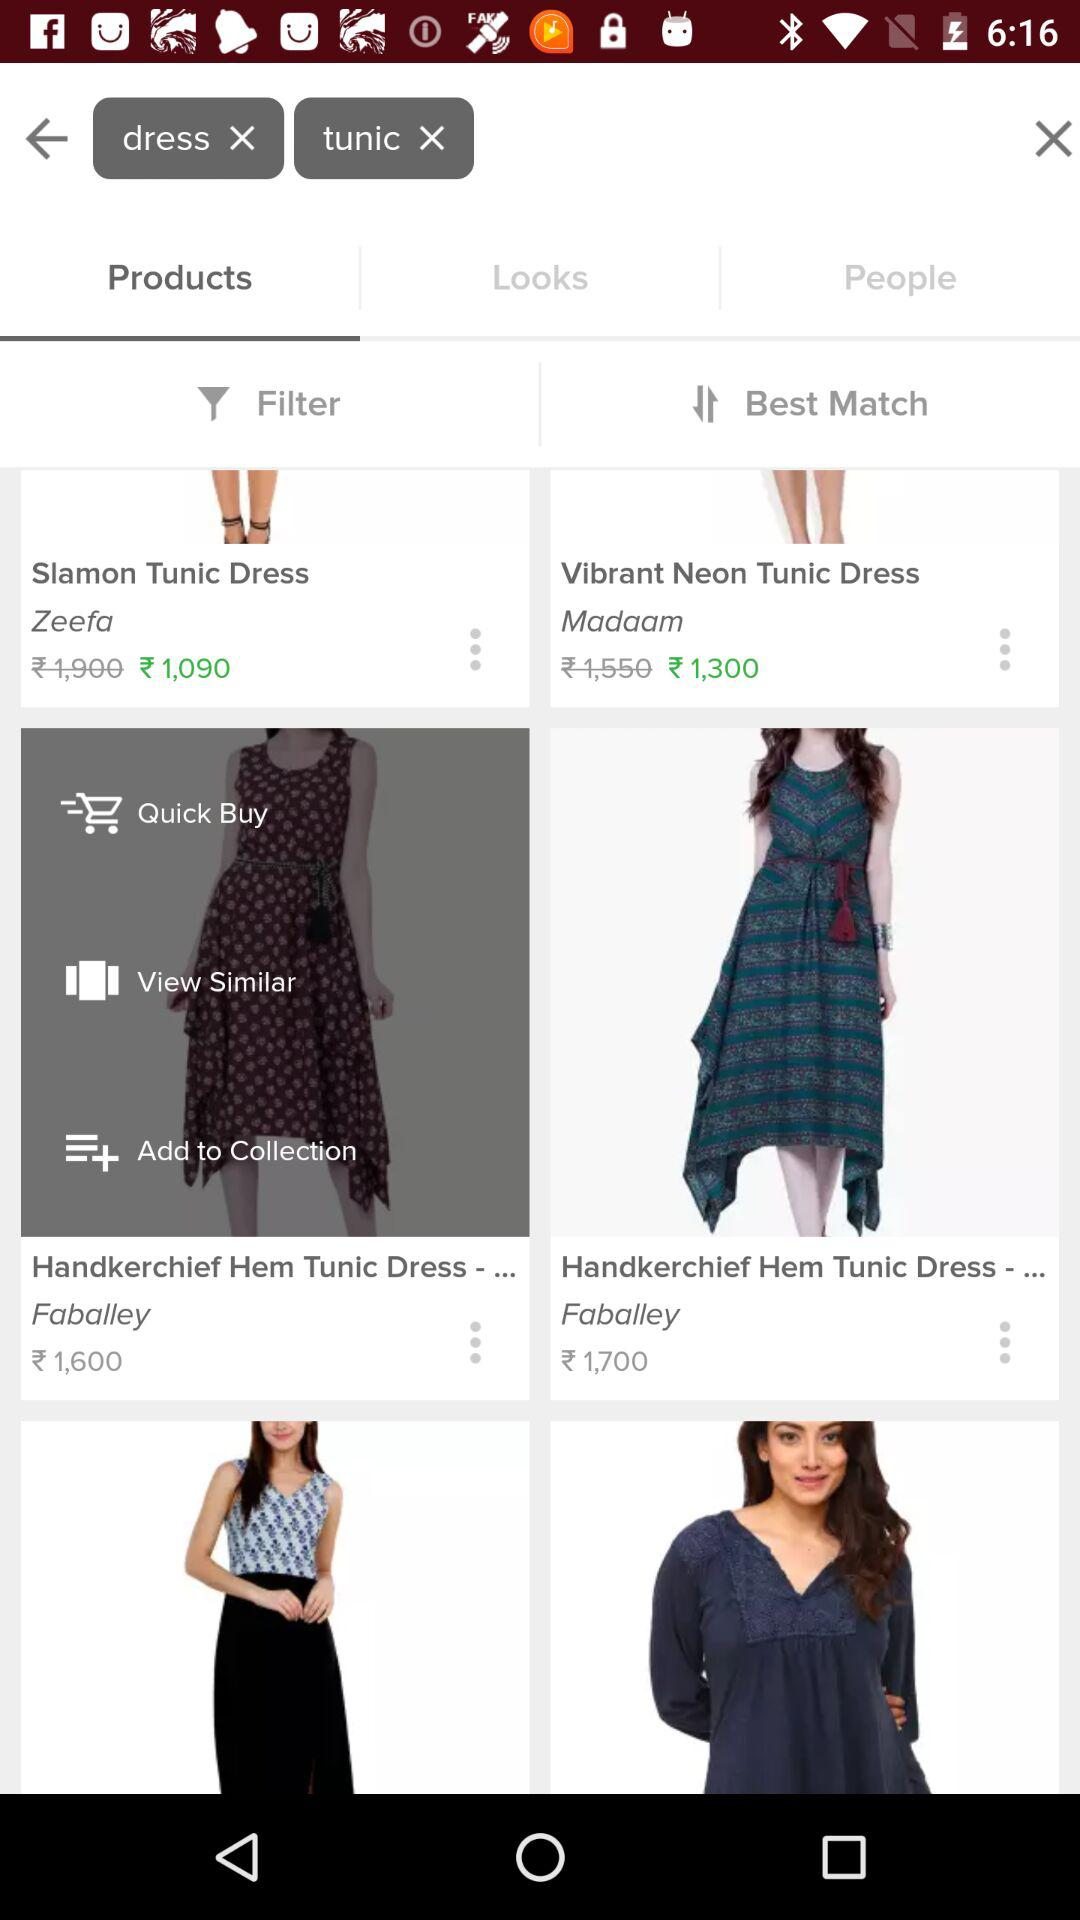What is the price of the "Slamon Tunic Dress"? The price is ₹1,090. 